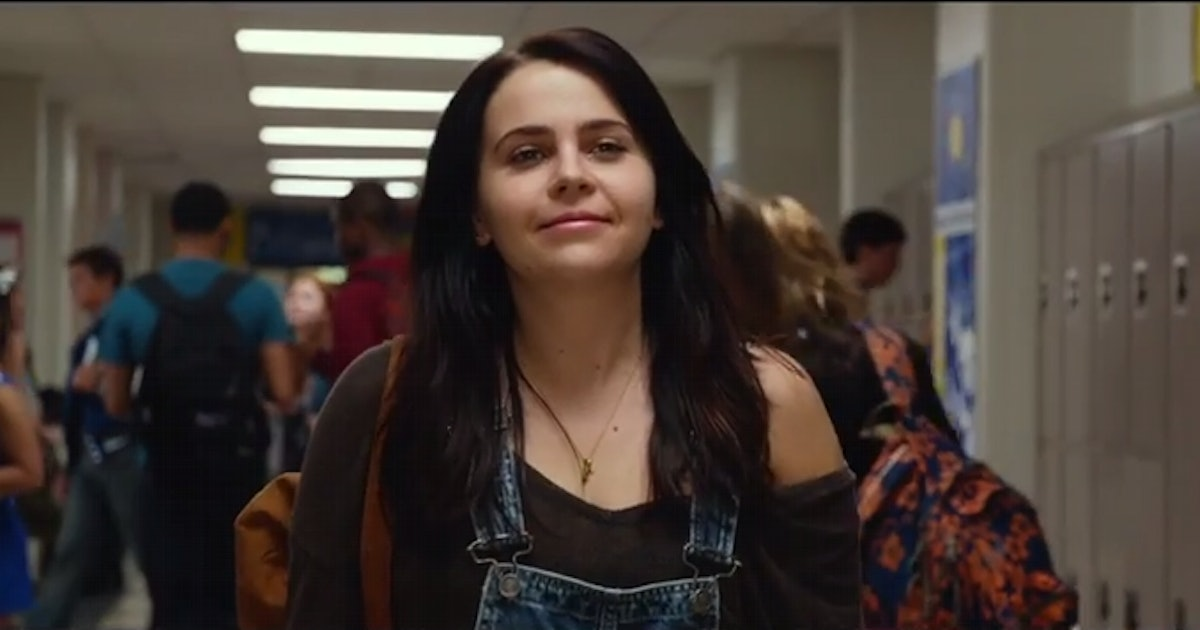What is this photo about? In this image, a character is seen walking down a bustling high school hallway. She is confidently gazing directly at the camera and sporting a slight smile. Her casual outfit consists of a brown cardigan over a black tank top, blue overalls, and a backpack slung over one shoulder, indicative of her being in transit between classes. The corridor is alive with activity as other students move in the opposite direction, creating a dynamic and lively atmosphere typical of a busy school day. 